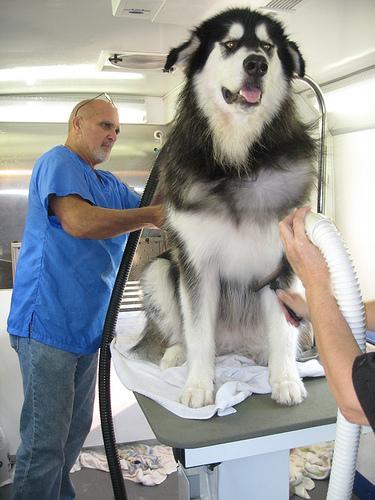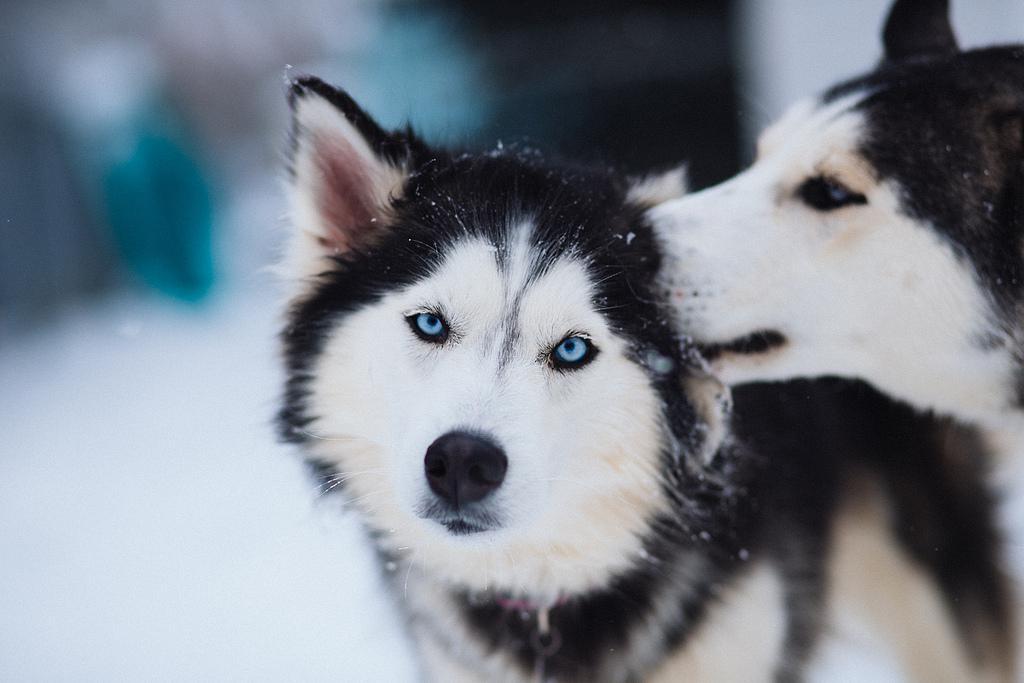The first image is the image on the left, the second image is the image on the right. Analyze the images presented: Is the assertion "The right and left image contains the same number of dogs huskeys." valid? Answer yes or no. No. 